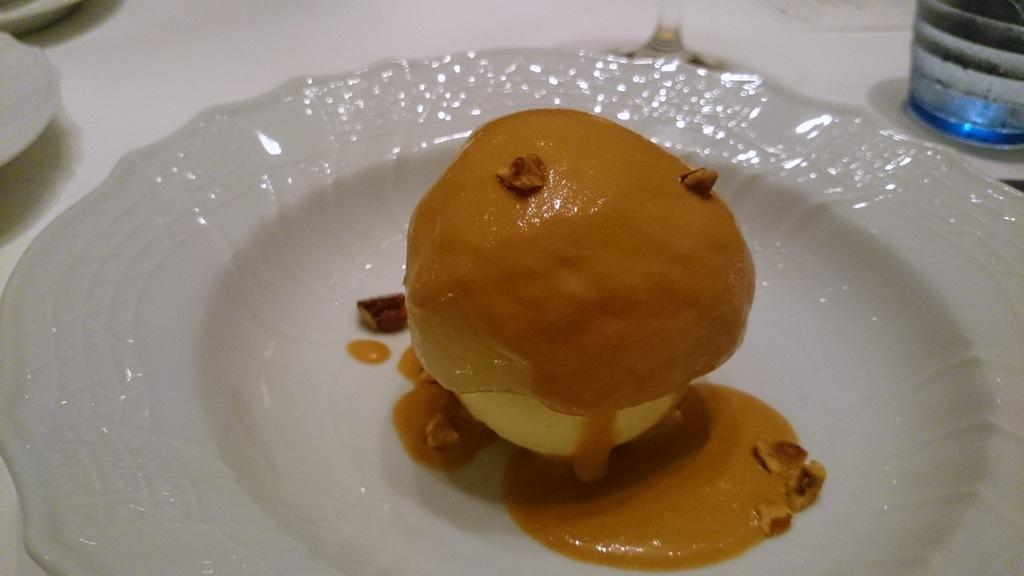What type of dishware can be seen in the image? There are plates in the image. What else can be seen in the image besides the plates? There is a glass and a bottle in the image. What is on the plate in the image? The plate contains a food item. What is the price of the cup in the image? There is no cup present in the image, so it is not possible to determine its price. 